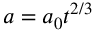<formula> <loc_0><loc_0><loc_500><loc_500>a = a _ { 0 } t ^ { 2 / 3 }</formula> 